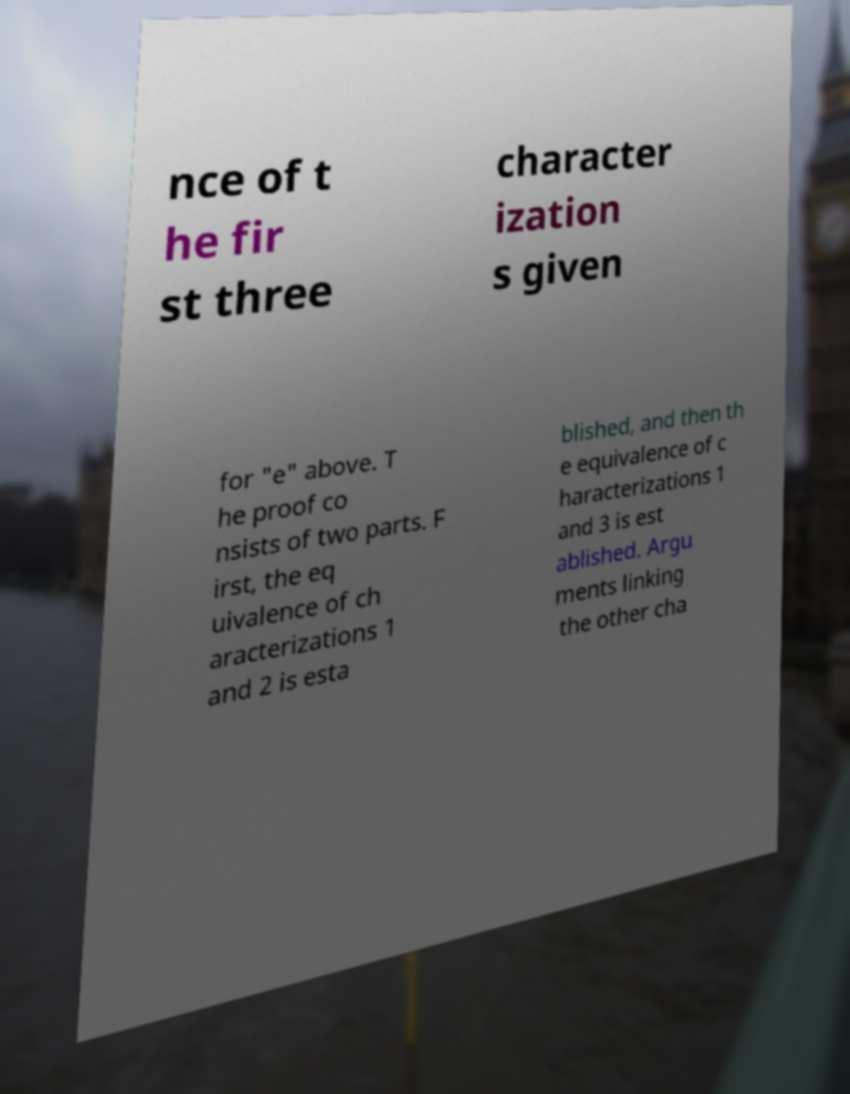Please read and relay the text visible in this image. What does it say? nce of t he fir st three character ization s given for "e" above. T he proof co nsists of two parts. F irst, the eq uivalence of ch aracterizations 1 and 2 is esta blished, and then th e equivalence of c haracterizations 1 and 3 is est ablished. Argu ments linking the other cha 